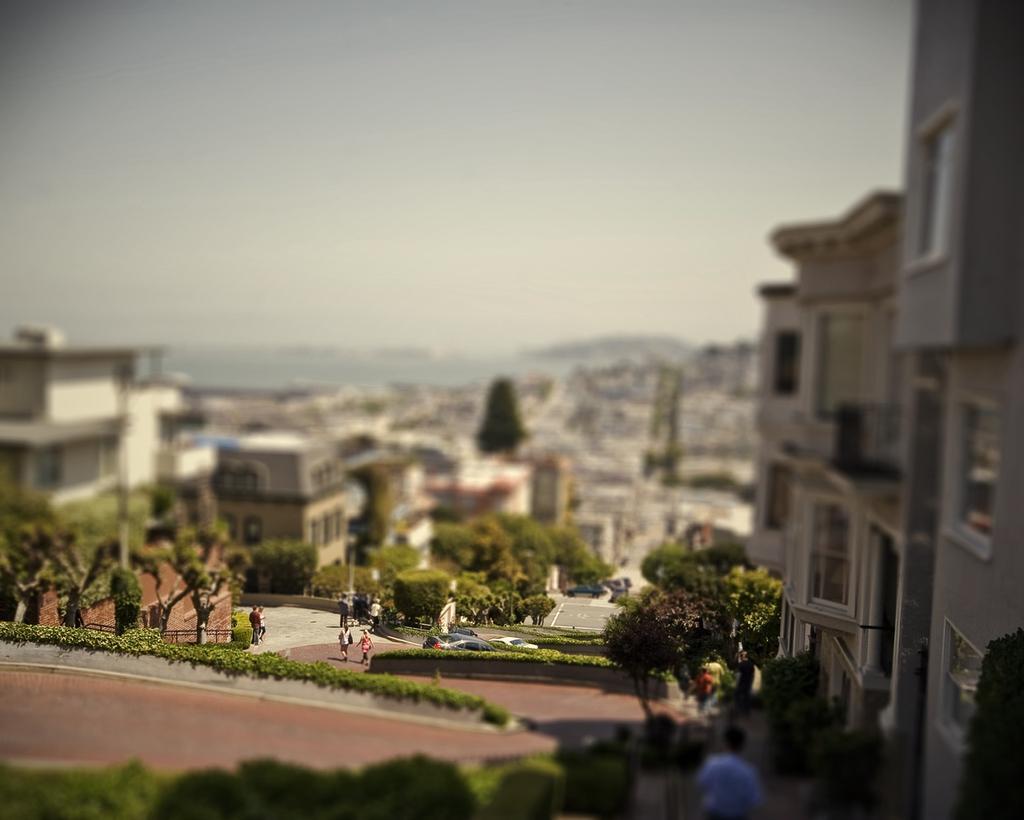Please provide a concise description of this image. In this image we can see many trees and plants. There are few people in the image. We can see the sky in the image. There is a walkway in the image. 